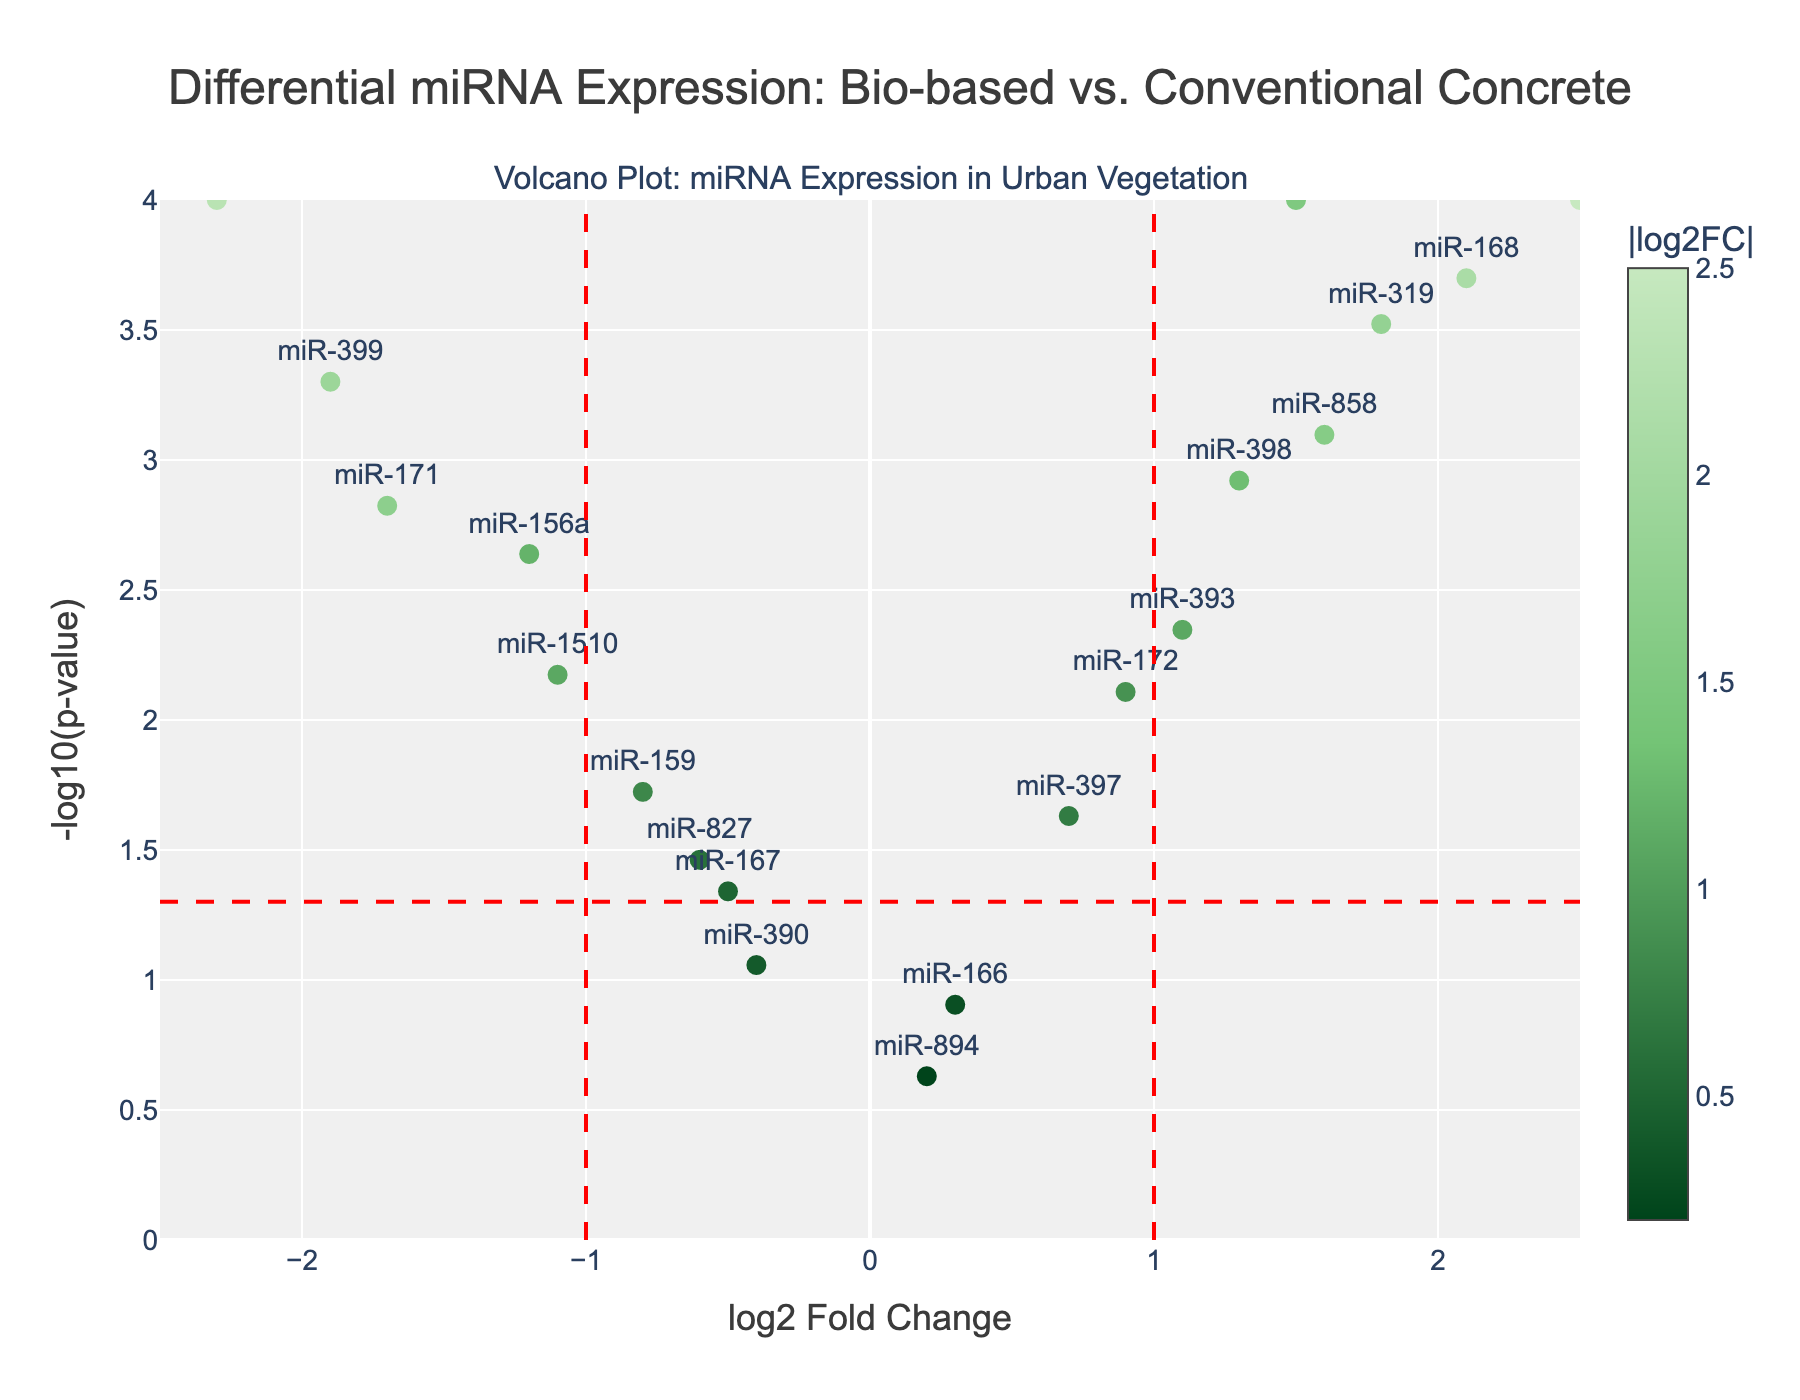What is the title of the plot? The title of the plot is located at the top center of the figure. It reads "Differential miRNA Expression: Bio-based vs. Conventional Concrete."
Answer: Differential miRNA Expression: Bio-based vs. Conventional Concrete How many miRNAs have a significant p-value (p < 0.05)? To determine the number of significant miRNAs, look for those data points above the horizontal red dashed line at -log10(0.05), which is approximately 1.3. Count those points.
Answer: 13 Which miRNA exhibits the highest log2 fold change? The highest log2 fold change is the rightmost data point. By referring to the hover information on the right, we identify this miRNA.
Answer: miR-408 How many miRNAs have a log2 fold change greater than 1? Examine the points to the right of the vertical dashed line at log2 fold change = 1. Count those points.
Answer: 3 Which miRNA has the most negative log2 fold change? The most negative log2 fold change is the leftmost data point. By referring to the hover information on the left, we identify this miRNA.
Answer: miR-396 Which miRNA has the lowest p-value? The lowest p-value corresponds to the highest -log10(p-value) value. Identify the highest data point and refer to the hover information.
Answer: miR-160 How many miRNAs have both a log2 fold change greater than 1 and a significant p-value? Look for points that are both to the right of the vertical dashed line at log2 fold change = 1 and above the horizontal dashed line at -log10(0.05). Count those points.
Answer: 3 What are the miRNAs with log2 fold changes between -1 and 1, but significant p-values? Identify points horizontally between the two vertical dashed lines at log2 fold change = -1 and 1, and vertically above the horizontal dashed line at -log10(0.05). List these miRNAs based on hover information.
Answer: miR-167, miR-827 Which has a larger absolute log2 fold change, miR-398 or miR-1510? By comparing the log2 fold changes of miR-398 (1.3) and miR-1510 (-1.1), we see that mir-398 has a larger absolute value.
Answer: miR-398 How many miRNAs fall into the highly upregulated category (log2 fold change > 1 and p-value < 0.001)? Look for the points to the right of the vertical dashed line at log2 fold change = 1, and above the horizontal line representing the significance cutoff at approximately -log10(0.001).
Answer: 2 